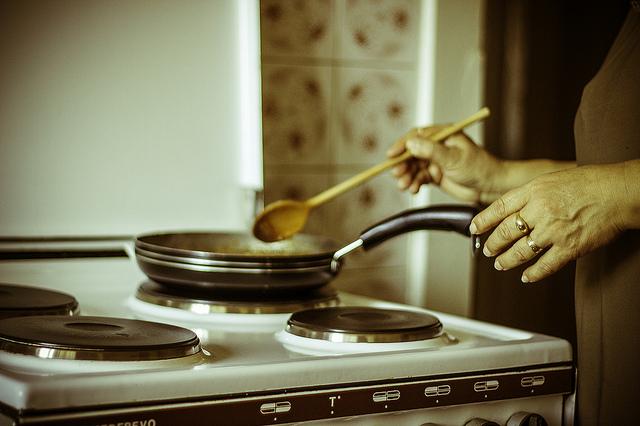Is this person married?
Be succinct. Yes. What cooking items are on the stove?
Concise answer only. Pan. What had is this person holding the spoon in?
Keep it brief. Right. What is the spoon made out of?
Give a very brief answer. Wood. 